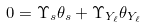<formula> <loc_0><loc_0><loc_500><loc_500>0 = \Upsilon _ { s } \theta _ { s } + \Upsilon _ { Y _ { \ell } } \theta _ { Y _ { \ell } }</formula> 